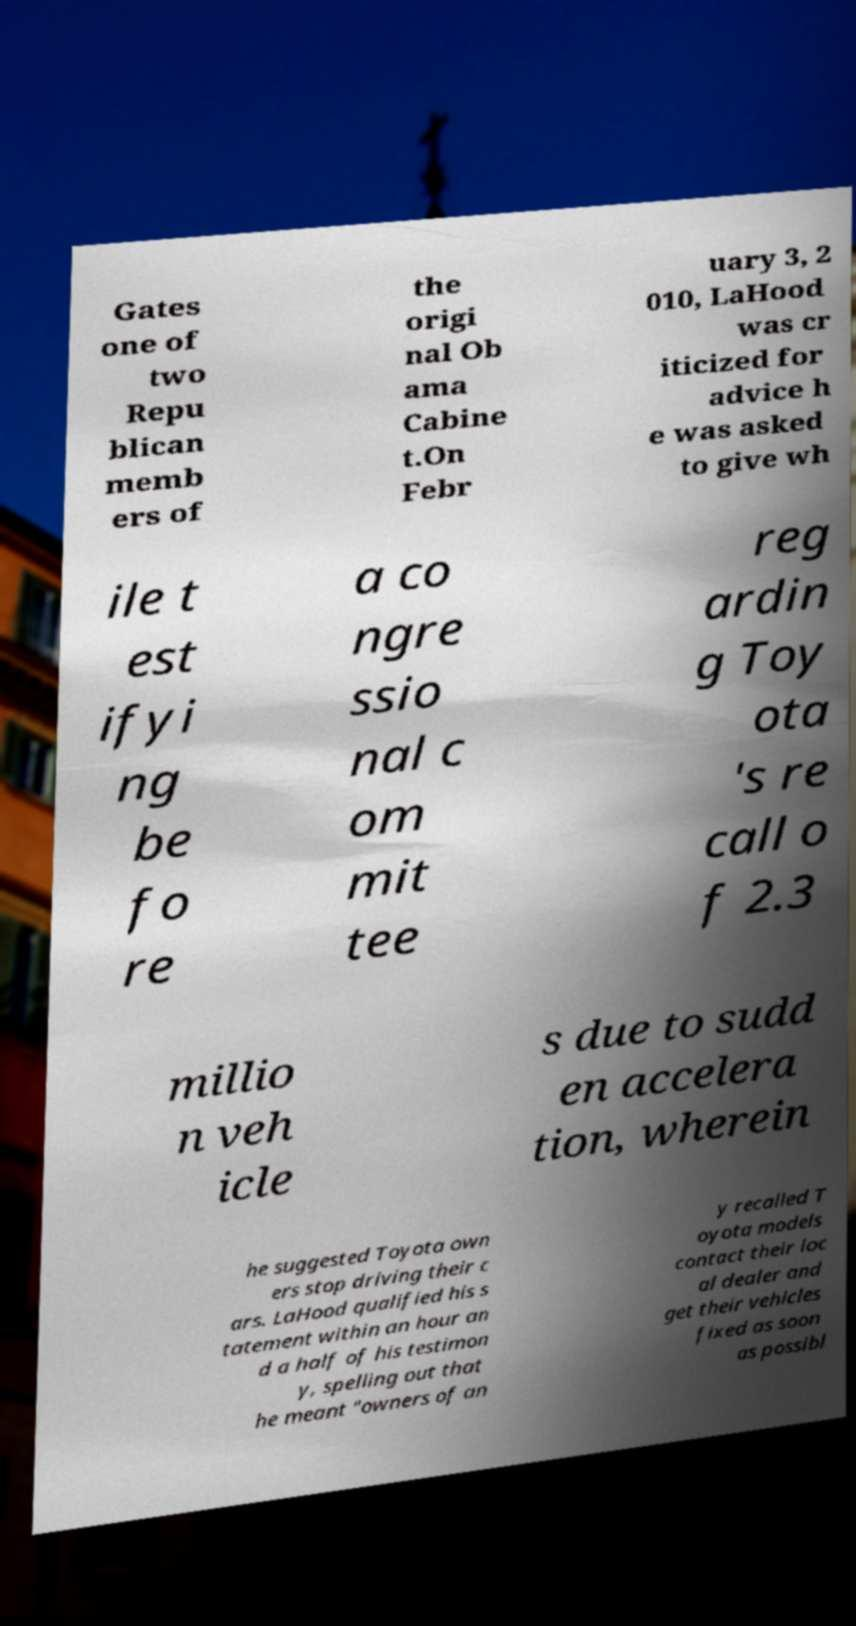Please read and relay the text visible in this image. What does it say? Gates one of two Repu blican memb ers of the origi nal Ob ama Cabine t.On Febr uary 3, 2 010, LaHood was cr iticized for advice h e was asked to give wh ile t est ifyi ng be fo re a co ngre ssio nal c om mit tee reg ardin g Toy ota 's re call o f 2.3 millio n veh icle s due to sudd en accelera tion, wherein he suggested Toyota own ers stop driving their c ars. LaHood qualified his s tatement within an hour an d a half of his testimon y, spelling out that he meant "owners of an y recalled T oyota models contact their loc al dealer and get their vehicles fixed as soon as possibl 